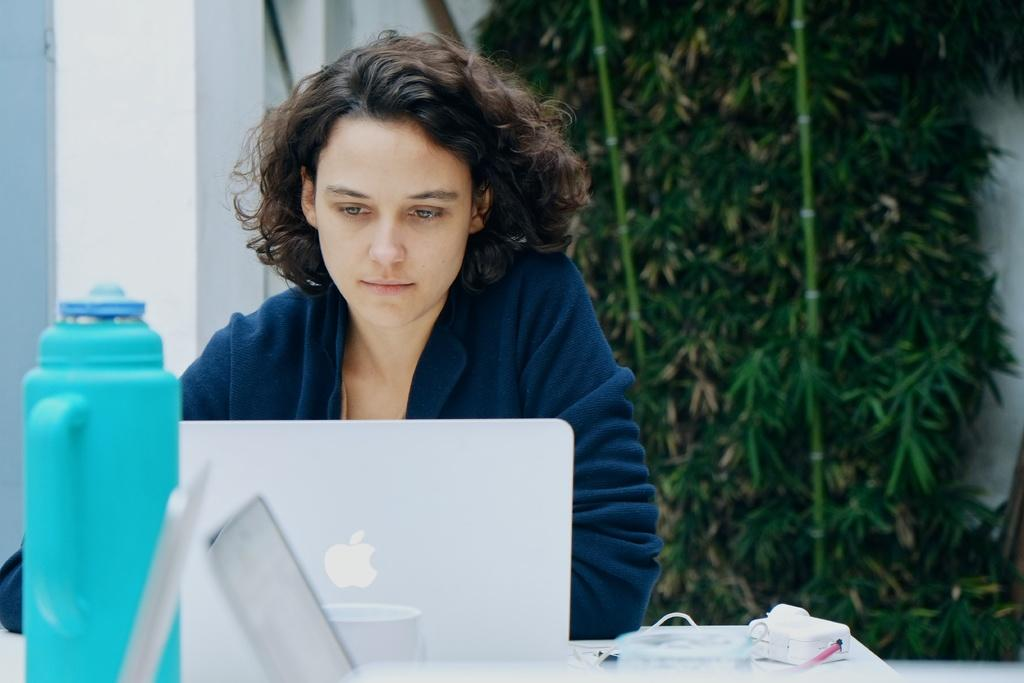What is the color of the wall in the image? The wall in the image is white. What type of plant can be seen in the image? There is a tree in the image. What piece of furniture is present in the image? There is a table in the image. Who is present in the image? There is a woman in the image. What objects are on the table in the image? There is a bottle and a laptop on the table in the image. Can you tell me how many owls are sitting on the tree in the image? There are no owls present in the image; it features a tree, a table, a woman, a bottle, and a laptop. What type of party is happening in the image? There is no party depicted in the image; it shows a woman sitting at a table with a tree in the background. 